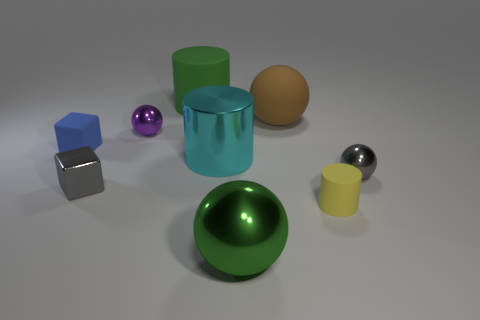Are there any patterns or consistencies in the arrangement of the objects? There is no immediately discernible pattern in the arrangement of the objects; however, the objects are placed with some spacing, suggesting an intentional layout. This configuration allows each object to be observed separately, without overlapping, making it easier to evaluate their shapes and surfaces individually. 